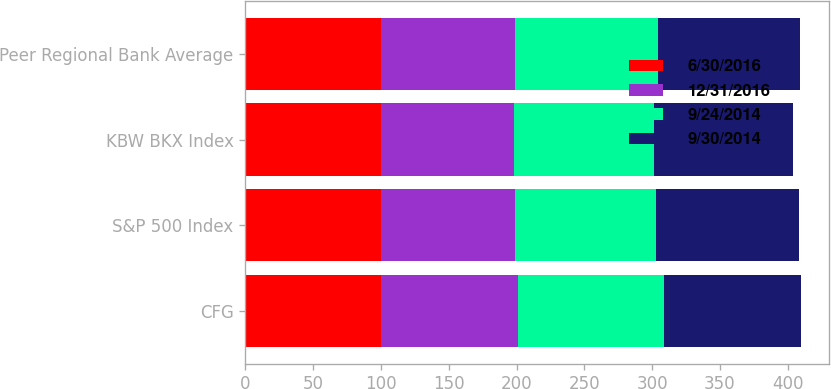Convert chart. <chart><loc_0><loc_0><loc_500><loc_500><stacked_bar_chart><ecel><fcel>CFG<fcel>S&P 500 Index<fcel>KBW BKX Index<fcel>Peer Regional Bank Average<nl><fcel>6/30/2016<fcel>100<fcel>100<fcel>100<fcel>100<nl><fcel>12/31/2016<fcel>101<fcel>99<fcel>98<fcel>99<nl><fcel>9/24/2014<fcel>108<fcel>104<fcel>103<fcel>105<nl><fcel>9/30/2014<fcel>101<fcel>105<fcel>103<fcel>105<nl></chart> 